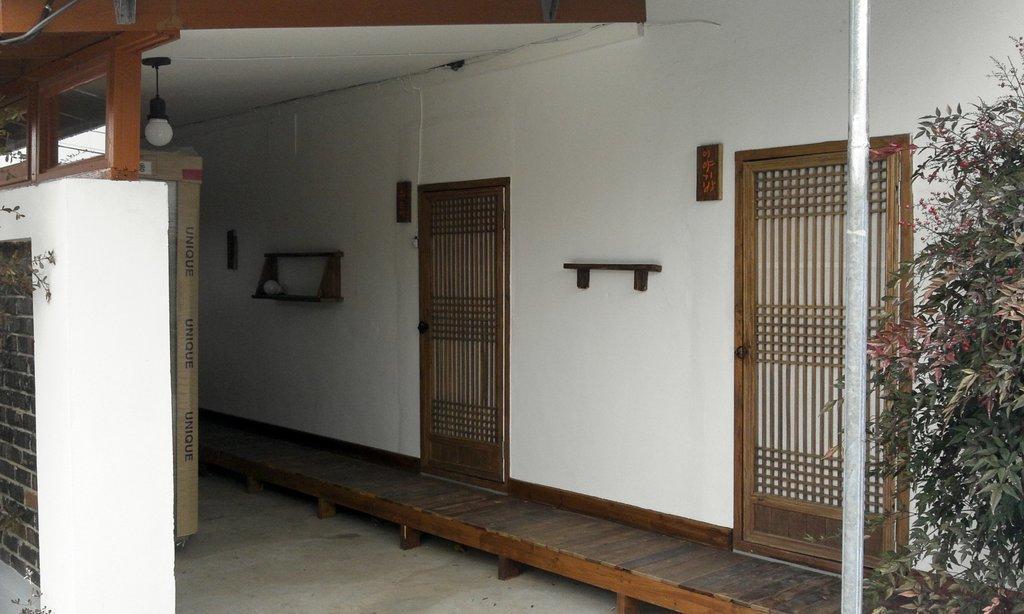Please provide a concise description of this image. In this image there is a wall, there are objects on the wall, there are doors, there is a plant towards the right of the image, there is a pole, there is a wall towards the left of the image, there is roof towards the top of the image, there is a light, there is an object on the ground. 